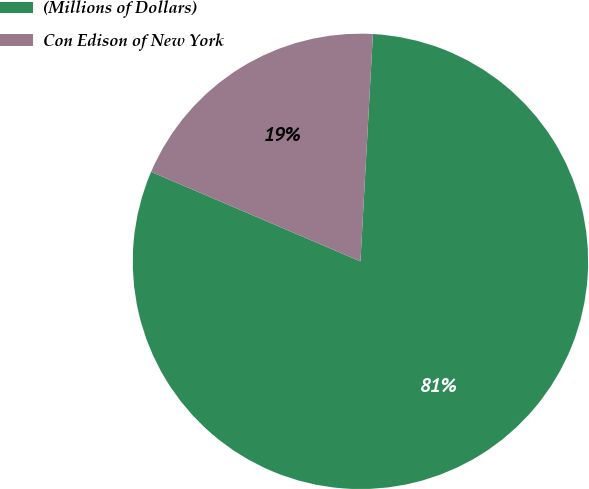Convert chart. <chart><loc_0><loc_0><loc_500><loc_500><pie_chart><fcel>(Millions of Dollars)<fcel>Con Edison of New York<nl><fcel>80.56%<fcel>19.44%<nl></chart> 